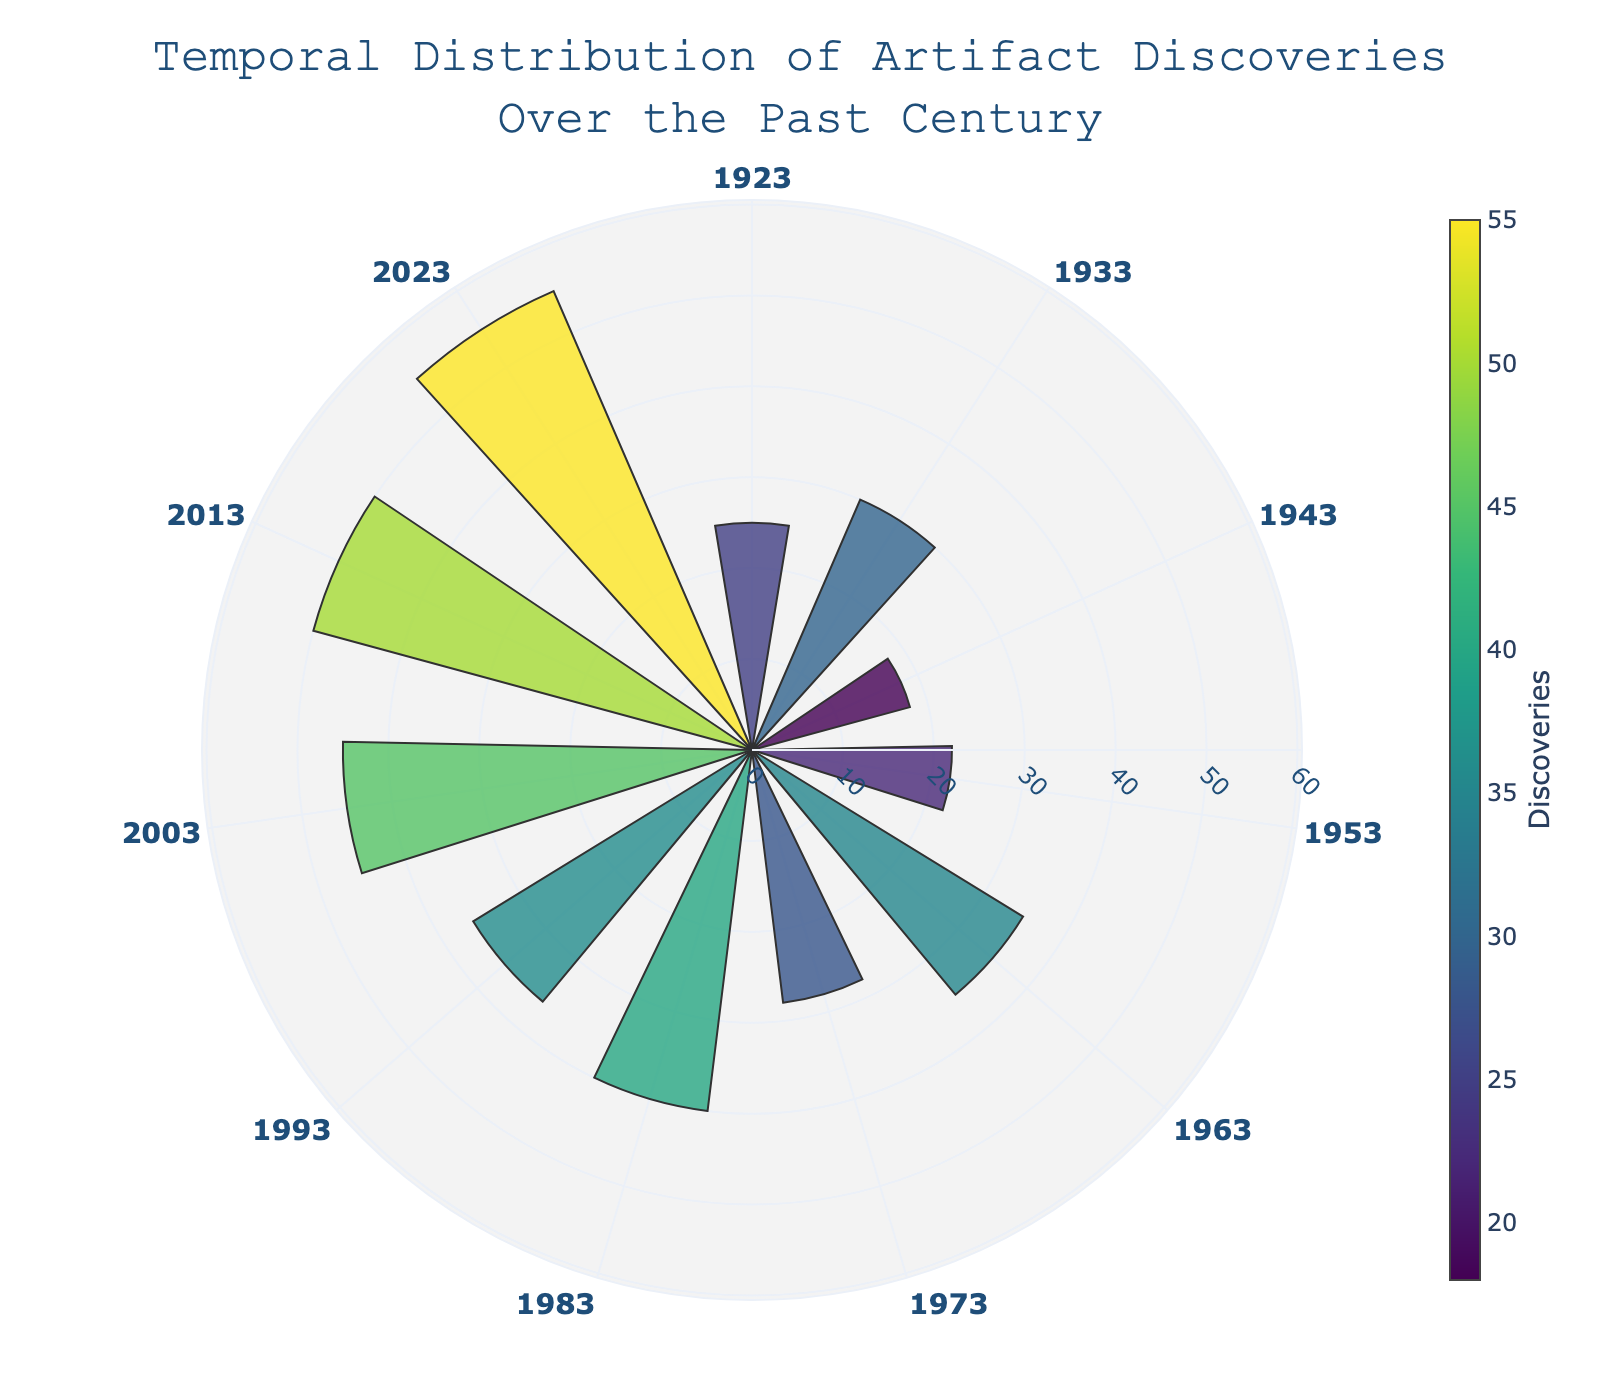What is the title of the figure? The title is displayed prominently at the top of the figure and reads "Temporal Distribution of Artifact Discoveries Over the Past Century".
Answer: Temporal Distribution of Artifact Discoveries Over the Past Century Which year had the highest number of artifact discoveries? By observing the plot, the longest bar represents the year with the highest number of artifact discoveries, which is 2023 with 55 discoveries.
Answer: 2023 Which two years have the closest number of artifact discoveries? Looking at the bars' lengths, the years 1933 and 1973 have very similar heights, representing 30 and 28 discoveries, respectively.
Answer: 1933 and 1973 How has the number of discoveries changed from 1963 to 1973? To determine this, we observe the bar lengths for 1963 and 1973. In 1963, there were 35 discoveries, and in 1973, there were 28, indicating a decrease of 7 discoveries.
Answer: Decreased by 7 What is the average number of artifact discoveries per decade from the given data? To find the average, sum all the discoveries and divide by the number of years: (25+30+18+22+35+28+40+36+45+50+55) / 11 = 384 / 11 ≈ 34.91.
Answer: Approximately 34.91 What is the median number of artifact discoveries over the past century? Arrange the discoveries in ascending order: [18, 22, 25, 28, 30, 35, 36, 40, 45, 50, 55]. The middle value is the 6th element since there is an odd number of data points, which is 35.
Answer: 35 Which decade experienced the largest growth in artifact discoveries compared to the previous decade? Calculate the differences between decades: 1933-1923 (5), 1943-1933 (-12), 1953-1943 (4), 1963-1953 (13), 1973-1963 (-7), 1983-1973 (12), 1993-1983 (-4), 2003-1993 (9), 2013-2003 (5), 2023-2013 (5). The largest growth is from 1963-1953, with an increase of 13.
Answer: 1963 to 1953 How many years had artifact discoveries exceeding 40? Examine the plot to count all the bars exceeding the 40 mark: 1983, 2003, 2013, and 2023, totaling 4 years.
Answer: 4 Between which two consecutive years did the most significant increase in discoveries occur? Calculate the increase between each consecutive year: 1933-1923 (5), 1943-1933 (-12), 1953-1943 (4), 1963-1953 (13), 1973-1963 (-7), 1983-1973 (12), 1993-1983 (-4), 2003-1993 (9), 2013-2003 (5), 2023-2013 (5). The most significant increase is 1963-1953 with 13.
Answer: 1963 and 1953 What is the trend in artifact discoveries over the past century? Observing the plot, it reflects a general upward trend in discoveries over the years, with dips and rises in certain decades.
Answer: Upward trend 